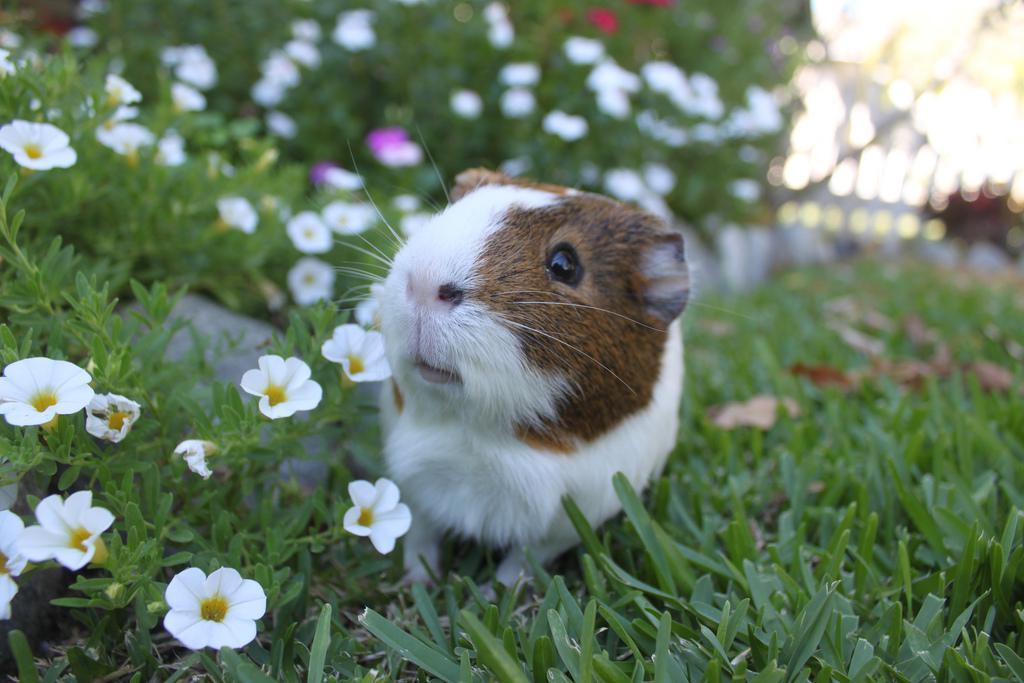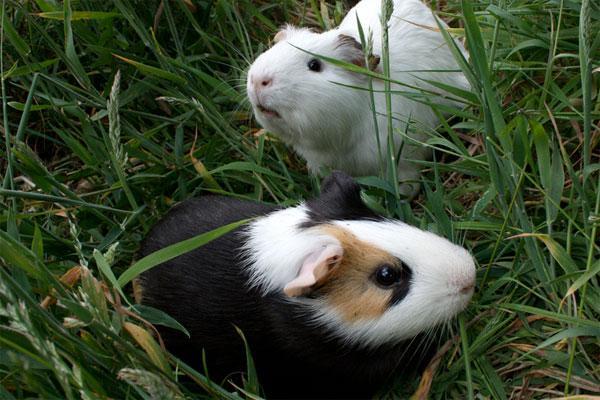The first image is the image on the left, the second image is the image on the right. Evaluate the accuracy of this statement regarding the images: "The left image shows a guinea pig standing on grass near tiny white flowers, and the right image shows one guinea pig with something yellowish in its mouth.". Is it true? Answer yes or no. No. The first image is the image on the left, the second image is the image on the right. Examine the images to the left and right. Is the description "One of the images features a guinea pig munching on foliage." accurate? Answer yes or no. No. 